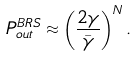<formula> <loc_0><loc_0><loc_500><loc_500>P _ { o u t } ^ { B R S } \approx \left ( \frac { 2 \gamma } { \bar { \gamma } } \right ) ^ { N } .</formula> 